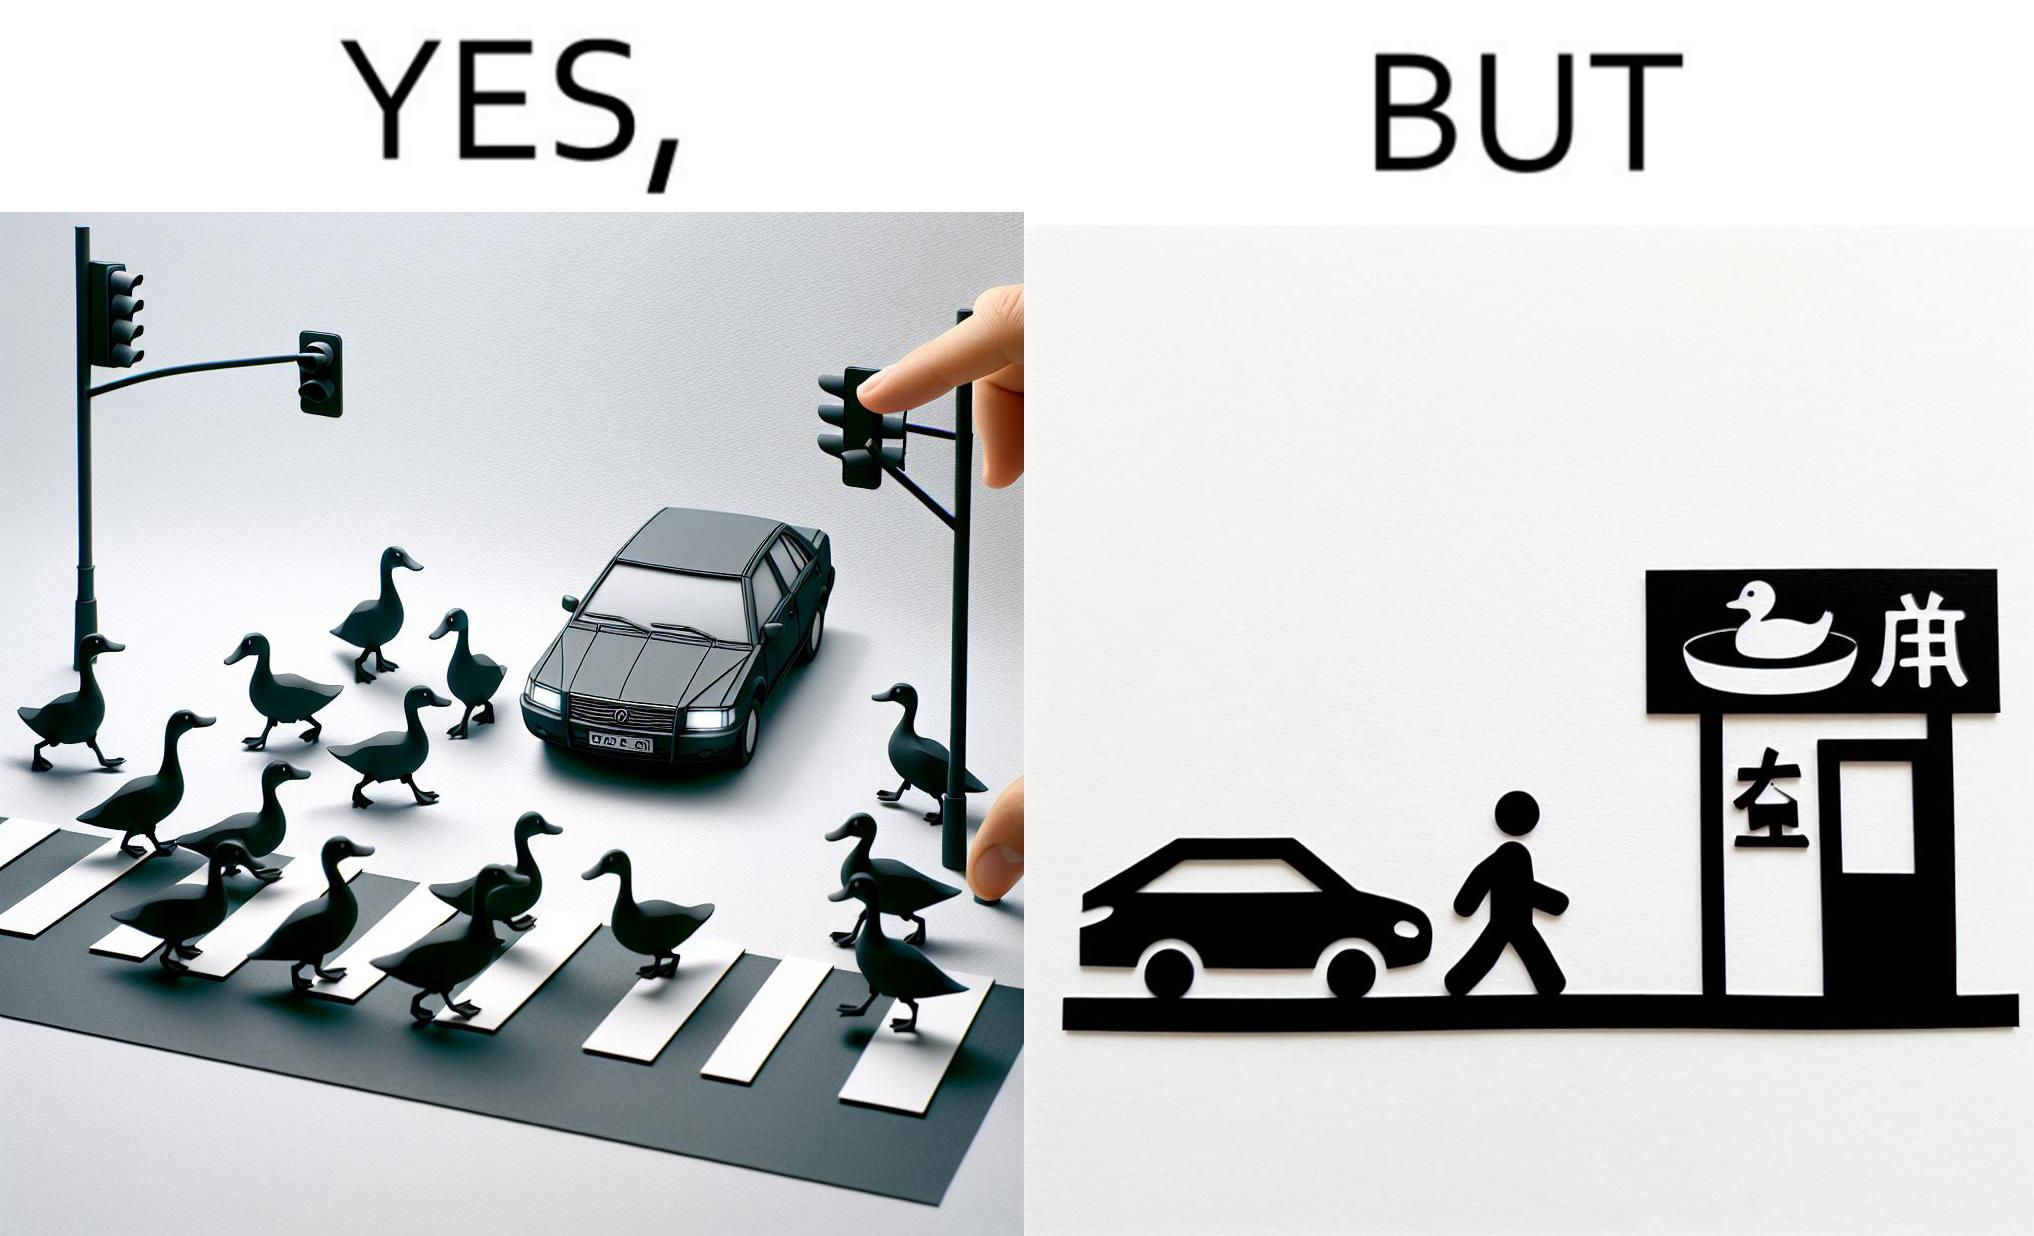Describe what you see in the left and right parts of this image. In the left part of the image: It is a car stopping to give way to queue of ducks crossing the road and allow them to cross safely In the right part of the image: It is a man parking his car and entering a peking duck shop 